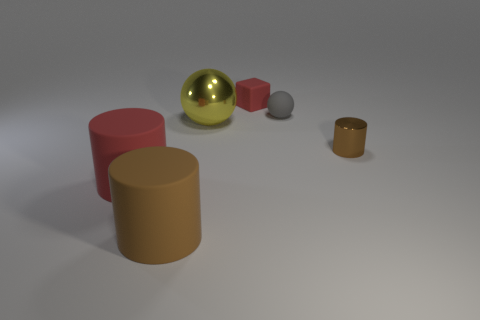Add 4 yellow objects. How many objects exist? 10 Subtract all blocks. How many objects are left? 5 Subtract 0 green blocks. How many objects are left? 6 Subtract all yellow metallic balls. Subtract all rubber cubes. How many objects are left? 4 Add 4 tiny things. How many tiny things are left? 7 Add 2 matte cylinders. How many matte cylinders exist? 4 